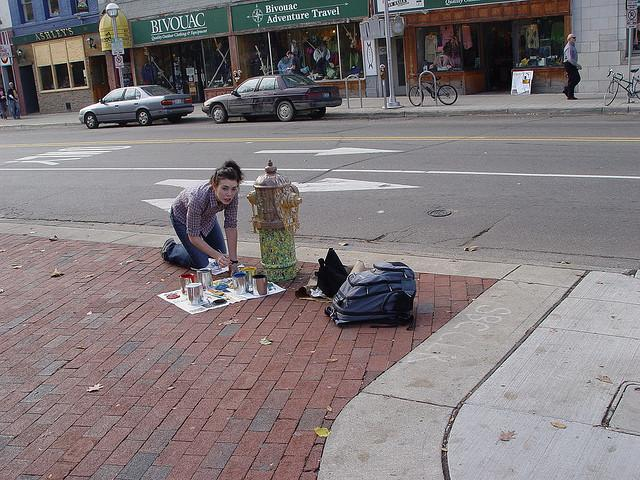What is the woman doing to the fire hydrant? painting 